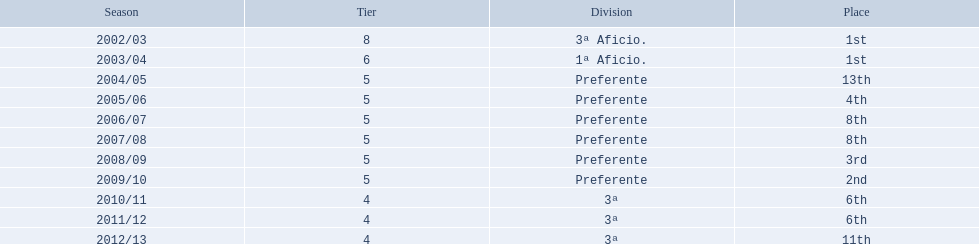In which tier four seasons did the games take place? 2010/11, 2011/12, 2012/13. Out of those seasons, which one had a 6th place finish? 2010/11, 2011/12. Which of the remaining seasons occurred most recently? 2011/12. 